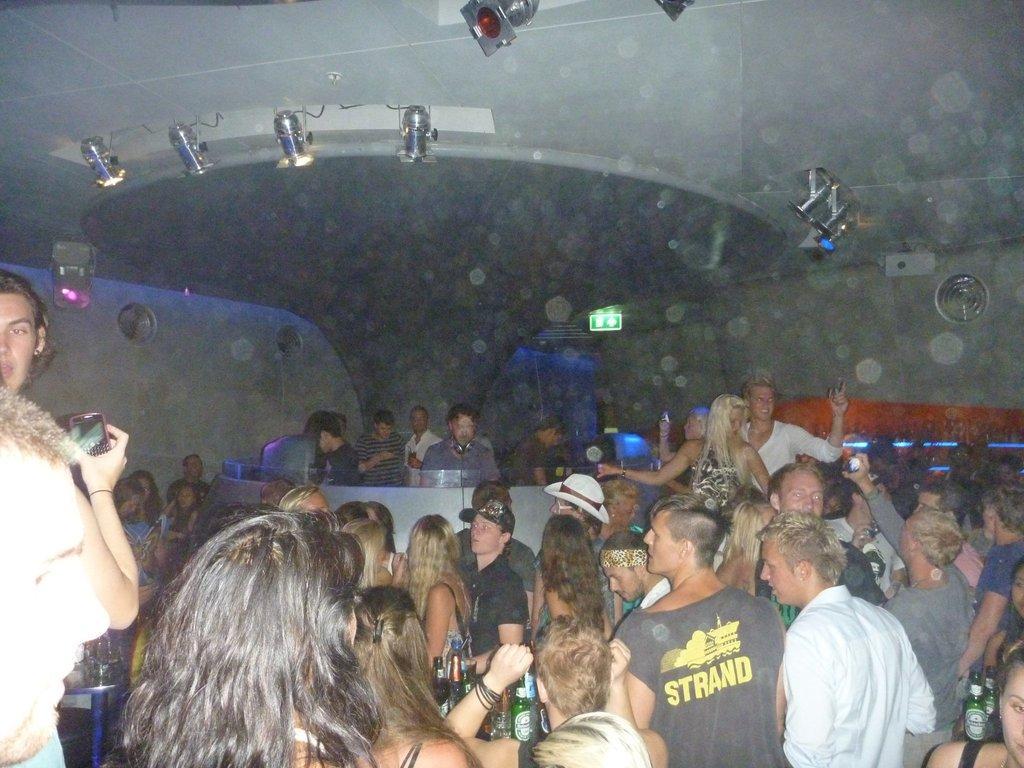In one or two sentences, can you explain what this image depicts? In this image we can see many people. There are bottles. Person on the left side is holding a mobile. At the top there are lights. There is a person wearing a hat. Another person is wearing a cap. In the back we can see a sign board. 